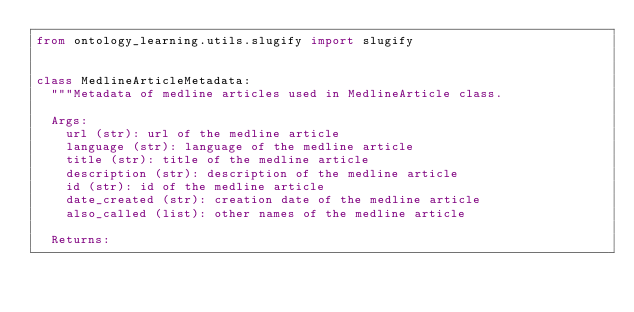<code> <loc_0><loc_0><loc_500><loc_500><_Python_>from ontology_learning.utils.slugify import slugify


class MedlineArticleMetadata:
	"""Metadata of medline articles used in MedlineArticle class.

	Args:
		url (str): url of the medline article
		language (str): language of the medline article
		title (str): title of the medline article
		description (str): description of the medline article
		id (str): id of the medline article
		date_created (str): creation date of the medline article
		also_called (list): other names of the medline article

	Returns:</code> 